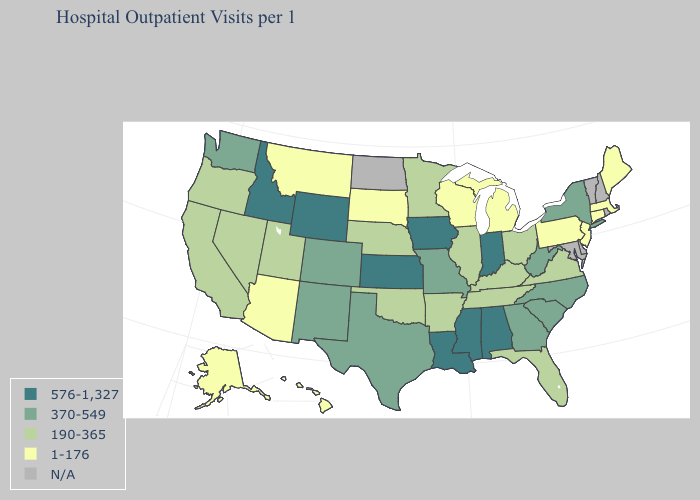What is the value of Iowa?
Concise answer only. 576-1,327. Name the states that have a value in the range 190-365?
Answer briefly. Arkansas, California, Florida, Illinois, Kentucky, Minnesota, Nebraska, Nevada, Ohio, Oklahoma, Oregon, Tennessee, Utah, Virginia. Which states have the highest value in the USA?
Write a very short answer. Alabama, Idaho, Indiana, Iowa, Kansas, Louisiana, Mississippi, Wyoming. Does the first symbol in the legend represent the smallest category?
Write a very short answer. No. Which states have the lowest value in the South?
Quick response, please. Arkansas, Florida, Kentucky, Oklahoma, Tennessee, Virginia. Which states have the lowest value in the MidWest?
Quick response, please. Michigan, South Dakota, Wisconsin. What is the highest value in the USA?
Give a very brief answer. 576-1,327. Which states have the highest value in the USA?
Answer briefly. Alabama, Idaho, Indiana, Iowa, Kansas, Louisiana, Mississippi, Wyoming. Which states hav the highest value in the Northeast?
Keep it brief. New York. Name the states that have a value in the range 1-176?
Keep it brief. Alaska, Arizona, Connecticut, Hawaii, Maine, Massachusetts, Michigan, Montana, New Jersey, Pennsylvania, South Dakota, Wisconsin. Is the legend a continuous bar?
Write a very short answer. No. What is the highest value in states that border Arkansas?
Be succinct. 576-1,327. Does Connecticut have the lowest value in the USA?
Be succinct. Yes. What is the highest value in the USA?
Quick response, please. 576-1,327. 